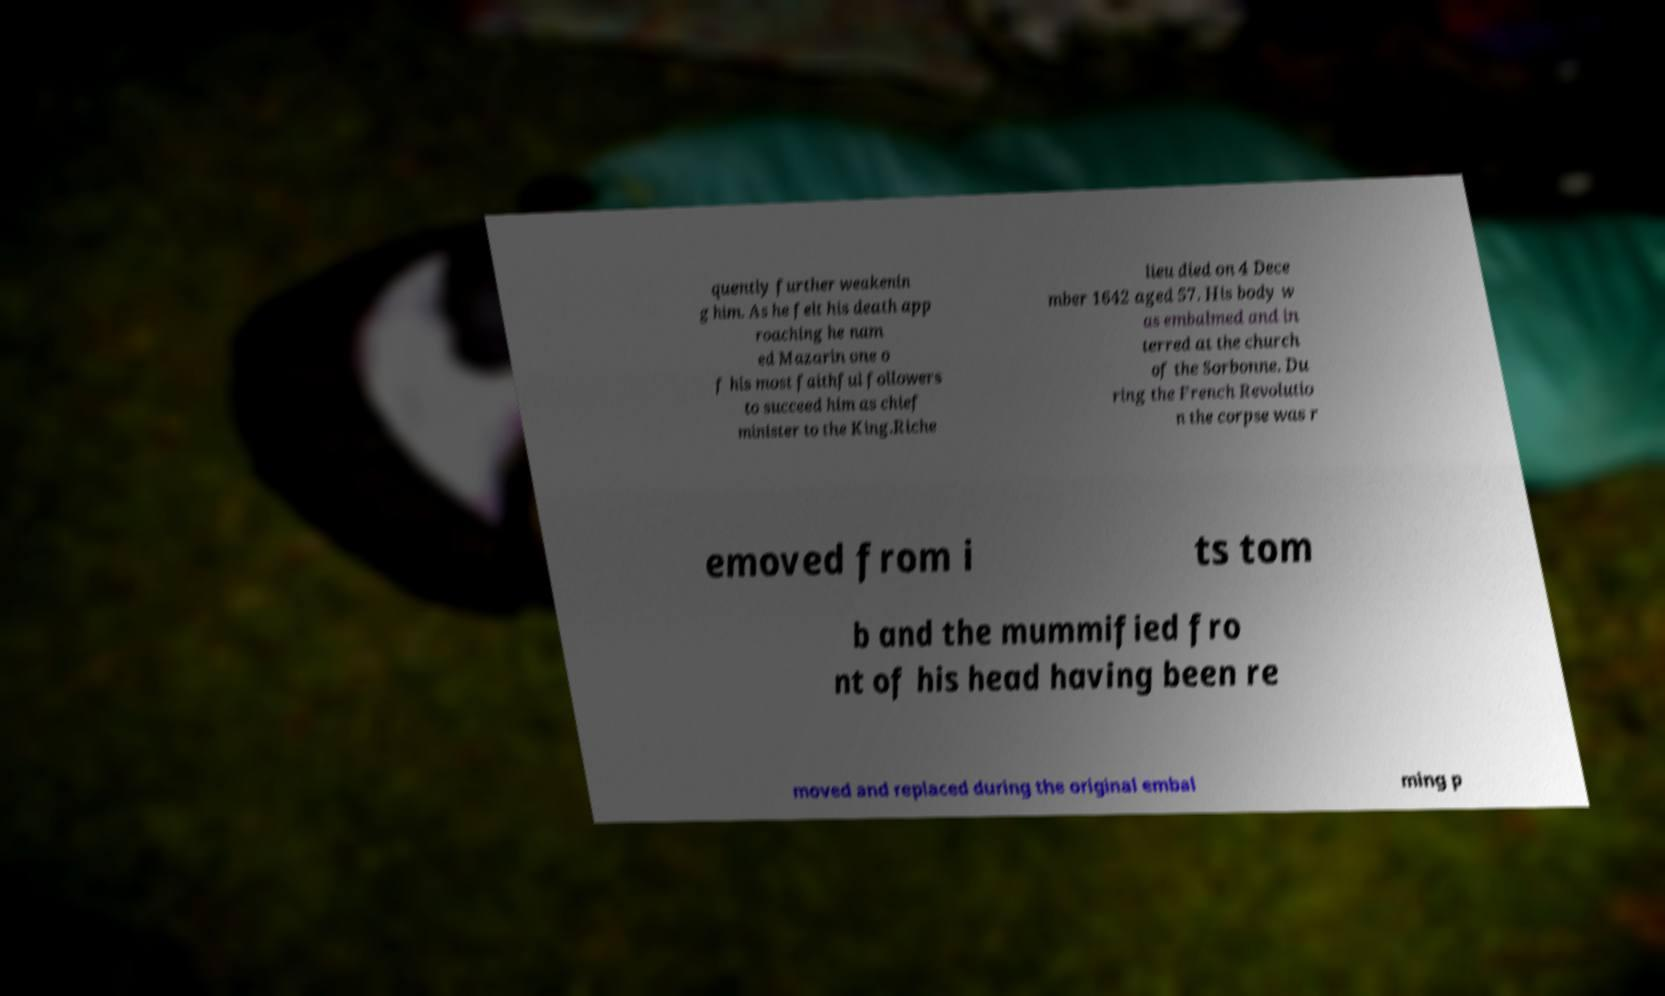What messages or text are displayed in this image? I need them in a readable, typed format. quently further weakenin g him. As he felt his death app roaching he nam ed Mazarin one o f his most faithful followers to succeed him as chief minister to the King.Riche lieu died on 4 Dece mber 1642 aged 57. His body w as embalmed and in terred at the church of the Sorbonne. Du ring the French Revolutio n the corpse was r emoved from i ts tom b and the mummified fro nt of his head having been re moved and replaced during the original embal ming p 